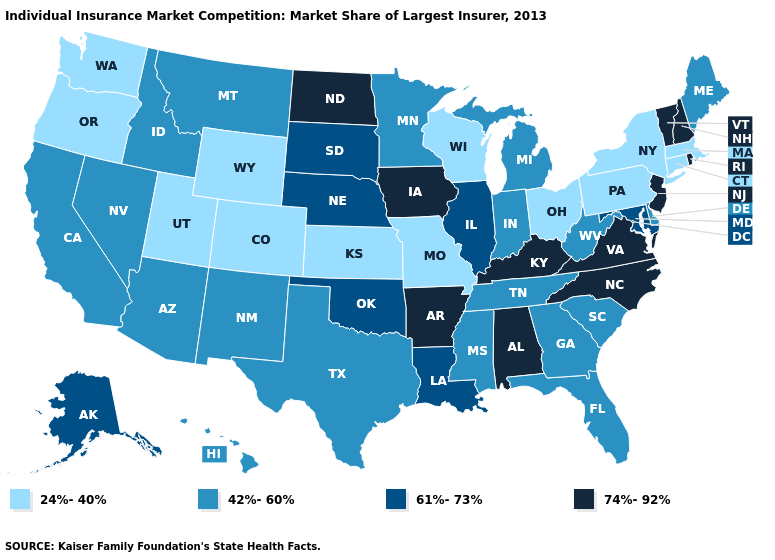What is the lowest value in the USA?
Quick response, please. 24%-40%. What is the value of Nebraska?
Quick response, please. 61%-73%. What is the value of Arizona?
Concise answer only. 42%-60%. Name the states that have a value in the range 24%-40%?
Give a very brief answer. Colorado, Connecticut, Kansas, Massachusetts, Missouri, New York, Ohio, Oregon, Pennsylvania, Utah, Washington, Wisconsin, Wyoming. Name the states that have a value in the range 61%-73%?
Write a very short answer. Alaska, Illinois, Louisiana, Maryland, Nebraska, Oklahoma, South Dakota. Does the map have missing data?
Keep it brief. No. Does the map have missing data?
Concise answer only. No. What is the value of Montana?
Answer briefly. 42%-60%. Does Michigan have the lowest value in the USA?
Short answer required. No. Does Oregon have the lowest value in the West?
Short answer required. Yes. Which states have the highest value in the USA?
Quick response, please. Alabama, Arkansas, Iowa, Kentucky, New Hampshire, New Jersey, North Carolina, North Dakota, Rhode Island, Vermont, Virginia. What is the highest value in states that border Virginia?
Short answer required. 74%-92%. What is the lowest value in the USA?
Write a very short answer. 24%-40%. What is the highest value in states that border Oregon?
Give a very brief answer. 42%-60%. 